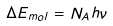<formula> <loc_0><loc_0><loc_500><loc_500>\Delta E _ { m o l } = N _ { A } h \nu</formula> 